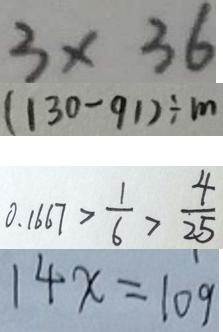<formula> <loc_0><loc_0><loc_500><loc_500>3 \times 3 6 
 ( 1 3 0 - 9 1 ) \div m 
 0 . 1 6 6 7 > \frac { 1 } { 6 } > \frac { 4 } { 2 5 } 
 1 4 x = 1 0 9</formula> 